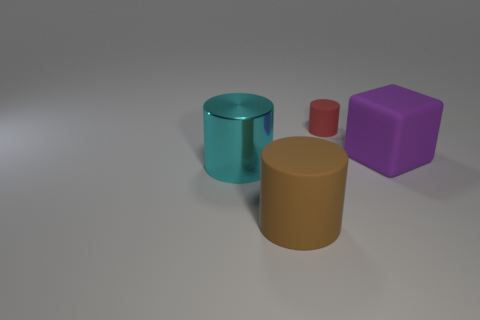Add 1 big brown rubber cylinders. How many objects exist? 5 Subtract all blocks. How many objects are left? 3 Add 3 matte things. How many matte things are left? 6 Add 2 blue cylinders. How many blue cylinders exist? 2 Subtract 0 red blocks. How many objects are left? 4 Subtract all big cyan things. Subtract all big purple matte things. How many objects are left? 2 